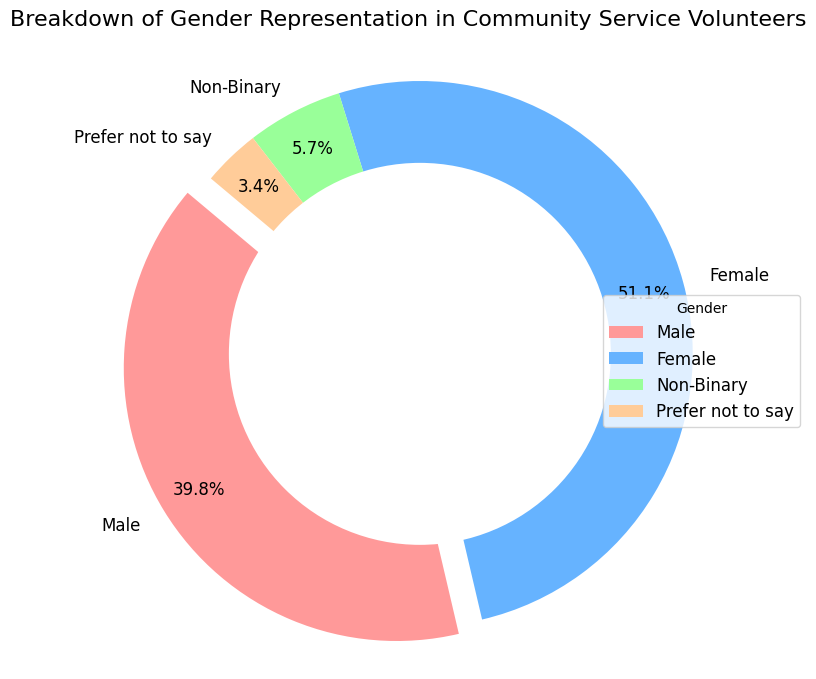Which gender has the highest representation in community service volunteers? By examining the figure, we see that the "Female" section has the largest size among the slices, indicating the highest representation.
Answer: Female What percentage of volunteers prefer not to disclose their gender? Refer to the labeling on the chart. The "Prefer not to say" slice is marked with a percentage; it is 3.3%.
Answer: 3.3% How many more female volunteers are there compared to male volunteers? From the data, there are 450 female volunteers and 350 male volunteers. Subtracting the counts gives 450 - 350 = 100.
Answer: 100 What is the combined percentage of non-binary and "prefer not to say" volunteers? The chart shows non-binary as 5.6% and "prefer not to say" as 3.3%. Adding these together, 5.6% + 3.3% = 8.9%.
Answer: 8.9% Which gender has the smallest representation in community service volunteers? The smallest slice in the figure belongs to the "Prefer not to say" group.
Answer: Prefer not to say What fraction of the volunteers are male? The chart shows that male volunteers make up 38.9% of the total. This fraction simplifies to approximately 39/100.
Answer: 39/100 Compare the representation of male and non-binary volunteers. How many times more male volunteers are there than non-binary volunteers? The data shows 350 male and 50 non-binary volunteers. Dividing the count of males by non-binary: 350 / 50 = 7.
Answer: 7 times What is the total number of volunteers? Summing up all the provided counts: 350 (male) + 450 (female) + 50 (non-binary) + 30 (prefer not to say) = 880.
Answer: 880 If we were to form a committee with one representative from each gender, what proportion of the total would this committee represent? Each gender-wise representative is 1 person, so 4 representatives in total. The total number of volunteers is 880. Therefore, the proportion is 4 / 880, which simplifies to 1 / 220.
Answer: 1/220 What is the difference in percentage points between female and male volunteers' representation? Female volunteers account for 51.1% and male volunteers for 38.9%. The difference is 51.1% - 38.9% = 12.2%.
Answer: 12.2% 